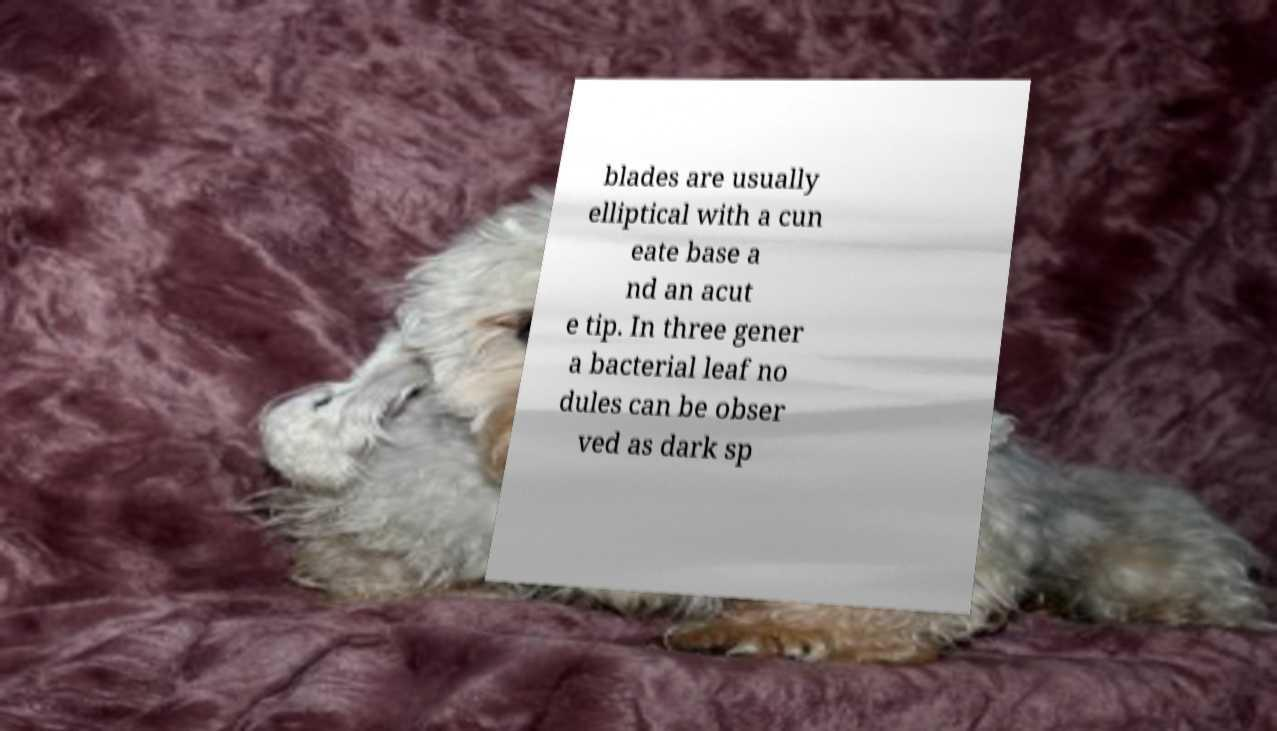Please read and relay the text visible in this image. What does it say? blades are usually elliptical with a cun eate base a nd an acut e tip. In three gener a bacterial leaf no dules can be obser ved as dark sp 